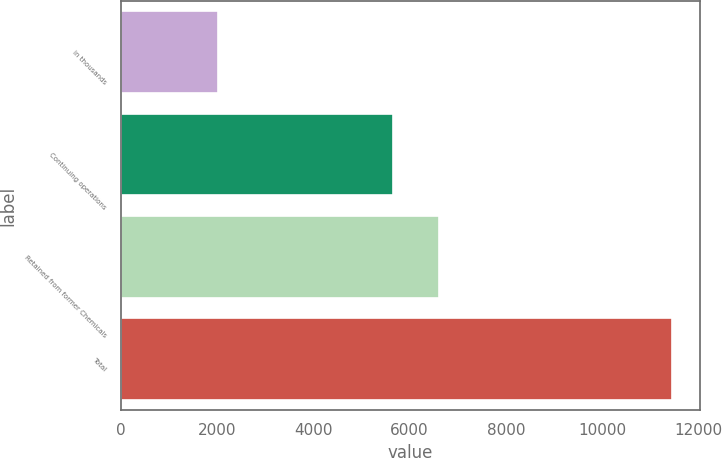Convert chart. <chart><loc_0><loc_0><loc_500><loc_500><bar_chart><fcel>in thousands<fcel>Continuing operations<fcel>Retained from former Chemicals<fcel>Total<nl><fcel>2012<fcel>5666<fcel>6610.6<fcel>11458<nl></chart> 